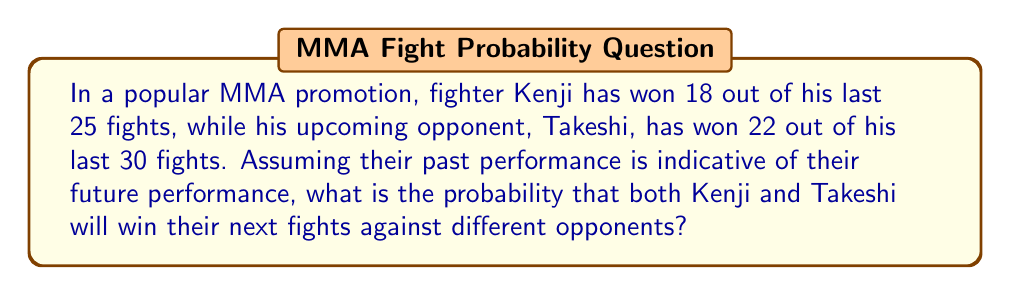Provide a solution to this math problem. To solve this problem, we need to follow these steps:

1. Calculate the probability of Kenji winning his next fight:
   $P(\text{Kenji wins}) = \frac{\text{Kenji's wins}}{\text{Kenji's total fights}} = \frac{18}{25} = 0.72$

2. Calculate the probability of Takeshi winning his next fight:
   $P(\text{Takeshi wins}) = \frac{\text{Takeshi's wins}}{\text{Takeshi's total fights}} = \frac{22}{30} \approx 0.7333$

3. Since we want the probability of both fighters winning their respective fights, and these events are independent (they're fighting different opponents), we multiply the individual probabilities:

   $P(\text{Both win}) = P(\text{Kenji wins}) \times P(\text{Takeshi wins})$

   $P(\text{Both win}) = 0.72 \times 0.7333 \approx 0.5280$

4. Convert the decimal to a percentage:
   $0.5280 \times 100\% = 52.80\%$

Therefore, the probability that both Kenji and Takeshi will win their next fights is approximately 52.80%.
Answer: 52.80% 